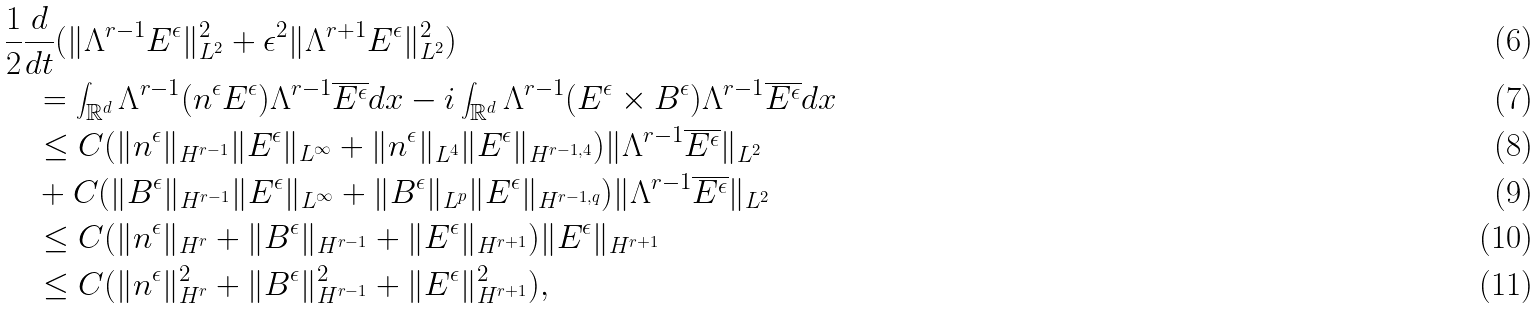<formula> <loc_0><loc_0><loc_500><loc_500>& \frac { 1 } { 2 } \frac { d } { d t } ( \| \Lambda ^ { r - 1 } E ^ { \epsilon } \| _ { L ^ { 2 } } ^ { 2 } + \epsilon ^ { 2 } \| \Lambda ^ { r + 1 } E ^ { \epsilon } \| _ { L ^ { 2 } } ^ { 2 } ) \\ & \quad = \int _ { \mathbb { R } ^ { d } } \Lambda ^ { r - 1 } ( n ^ { \epsilon } E ^ { \epsilon } ) \Lambda ^ { r - 1 } \overline { E ^ { \epsilon } } d x - i \int _ { \mathbb { R } ^ { d } } \Lambda ^ { r - 1 } ( E ^ { \epsilon } \times B ^ { \epsilon } ) \Lambda ^ { r - 1 } \overline { E ^ { \epsilon } } d x \\ & \quad \leq C ( \| n ^ { \epsilon } \| _ { H ^ { r - 1 } } \| E ^ { \epsilon } \| _ { L ^ { \infty } } + \| n ^ { \epsilon } \| _ { L ^ { 4 } } \| E ^ { \epsilon } \| _ { H ^ { r - 1 , 4 } } ) \| \Lambda ^ { r - 1 } \overline { E ^ { \epsilon } } \| _ { L ^ { 2 } } \\ & \quad + C ( \| B ^ { \epsilon } \| _ { H ^ { r - 1 } } \| E ^ { \epsilon } \| _ { L ^ { \infty } } + \| B ^ { \epsilon } \| _ { L ^ { p } } \| E ^ { \epsilon } \| _ { H ^ { r - 1 , q } } ) \| \Lambda ^ { r - 1 } \overline { E ^ { \epsilon } } \| _ { L ^ { 2 } } \\ & \quad \leq C ( \| n ^ { \epsilon } \| _ { H ^ { r } } + \| B ^ { \epsilon } \| _ { H ^ { r - 1 } } + \| E ^ { \epsilon } \| _ { H ^ { r + 1 } } ) \| E ^ { \epsilon } \| _ { H ^ { r + 1 } } \\ & \quad \leq C ( \| n ^ { \epsilon } \| _ { H ^ { r } } ^ { 2 } + \| B ^ { \epsilon } \| _ { H ^ { r - 1 } } ^ { 2 } + \| E ^ { \epsilon } \| _ { H ^ { r + 1 } } ^ { 2 } ) ,</formula> 